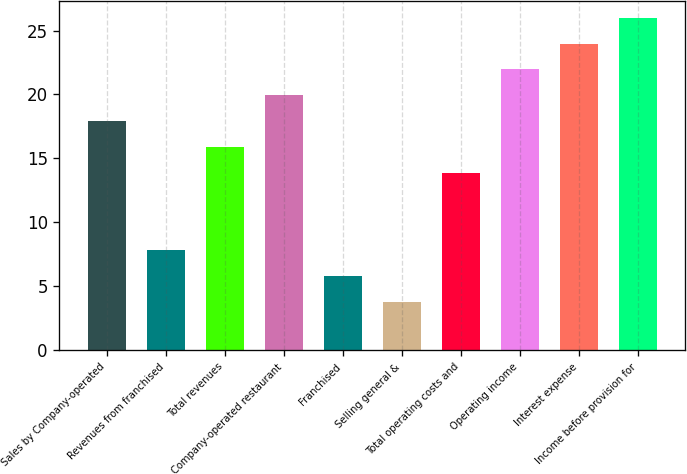Convert chart to OTSL. <chart><loc_0><loc_0><loc_500><loc_500><bar_chart><fcel>Sales by Company-operated<fcel>Revenues from franchised<fcel>Total revenues<fcel>Company-operated restaurant<fcel>Franchised<fcel>Selling general &<fcel>Total operating costs and<fcel>Operating income<fcel>Interest expense<fcel>Income before provision for<nl><fcel>17.92<fcel>7.82<fcel>15.9<fcel>19.94<fcel>5.8<fcel>3.78<fcel>13.88<fcel>21.96<fcel>23.98<fcel>26<nl></chart> 